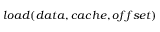Convert formula to latex. <formula><loc_0><loc_0><loc_500><loc_500>l o a d ( d a t a , c a c h e , o f f s e t )</formula> 